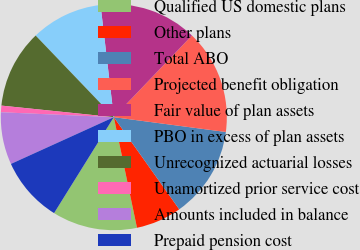Convert chart to OTSL. <chart><loc_0><loc_0><loc_500><loc_500><pie_chart><fcel>Qualified US domestic plans<fcel>Other plans<fcel>Total ABO<fcel>Projected benefit obligation<fcel>Fair value of plan assets<fcel>PBO in excess of plan assets<fcel>Unrecognized actuarial losses<fcel>Unamortized prior service cost<fcel>Amounts included in balance<fcel>Prepaid pension cost<nl><fcel>12.15%<fcel>6.54%<fcel>13.08%<fcel>14.95%<fcel>14.02%<fcel>10.28%<fcel>11.21%<fcel>0.94%<fcel>7.48%<fcel>9.35%<nl></chart> 